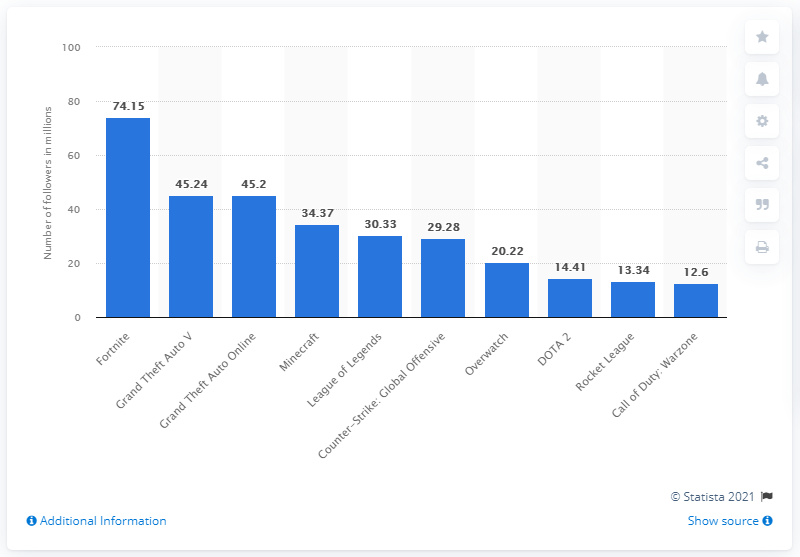Draw attention to some important aspects in this diagram. Fortnite is the most followed game on Twitch, with a significant number of followers and viewers. 